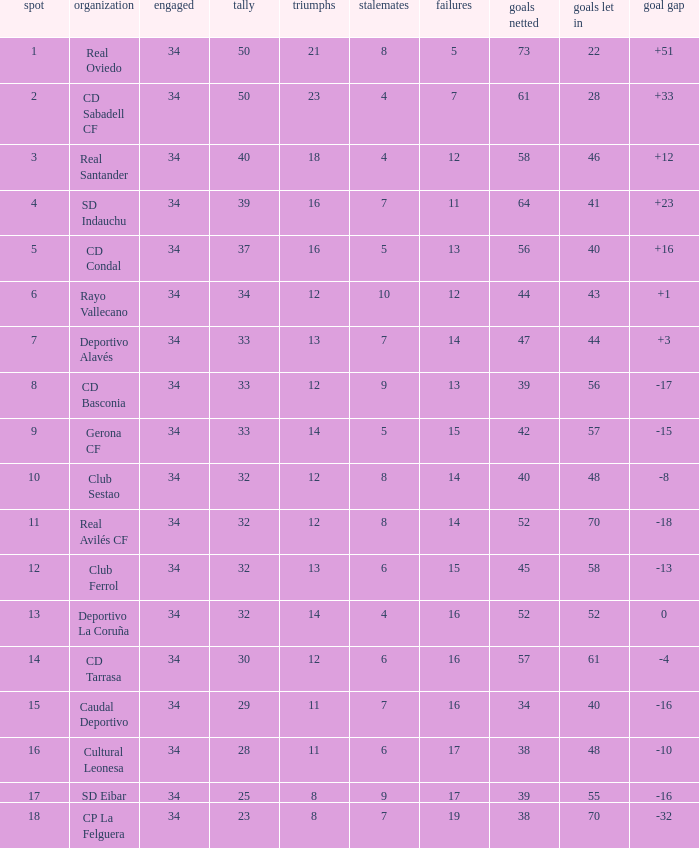Which Wins have a Goal Difference larger than 0, and Goals against larger than 40, and a Position smaller than 6, and a Club of sd indauchu? 16.0. 